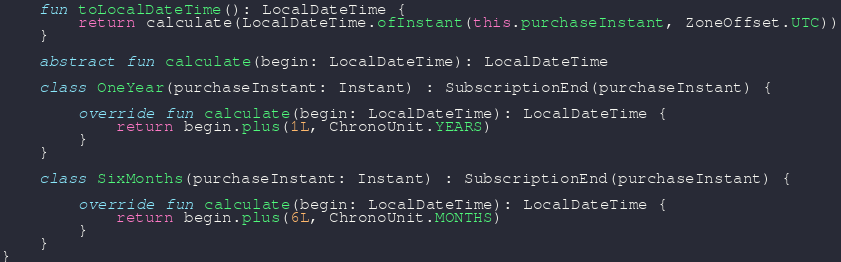<code> <loc_0><loc_0><loc_500><loc_500><_Kotlin_>
    fun toLocalDateTime(): LocalDateTime {
        return calculate(LocalDateTime.ofInstant(this.purchaseInstant, ZoneOffset.UTC))
    }

    abstract fun calculate(begin: LocalDateTime): LocalDateTime

    class OneYear(purchaseInstant: Instant) : SubscriptionEnd(purchaseInstant) {

        override fun calculate(begin: LocalDateTime): LocalDateTime {
            return begin.plus(1L, ChronoUnit.YEARS)
        }
    }

    class SixMonths(purchaseInstant: Instant) : SubscriptionEnd(purchaseInstant) {

        override fun calculate(begin: LocalDateTime): LocalDateTime {
            return begin.plus(6L, ChronoUnit.MONTHS)
        }
    }
}
</code> 